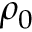Convert formula to latex. <formula><loc_0><loc_0><loc_500><loc_500>\rho _ { 0 }</formula> 